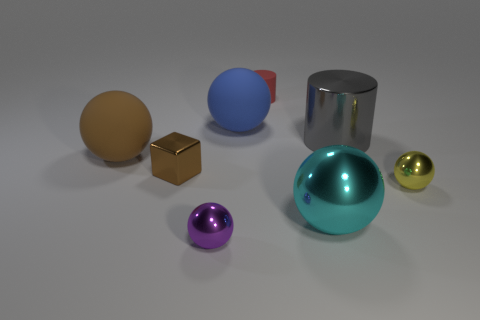Subtract 2 balls. How many balls are left? 3 Subtract all yellow spheres. How many spheres are left? 4 Subtract all cyan shiny balls. How many balls are left? 4 Subtract all purple balls. Subtract all red cylinders. How many balls are left? 4 Add 2 tiny purple shiny balls. How many objects exist? 10 Subtract all blocks. How many objects are left? 7 Add 4 shiny things. How many shiny things are left? 9 Add 5 small gray cubes. How many small gray cubes exist? 5 Subtract 0 purple blocks. How many objects are left? 8 Subtract all small brown shiny cubes. Subtract all large cyan spheres. How many objects are left? 6 